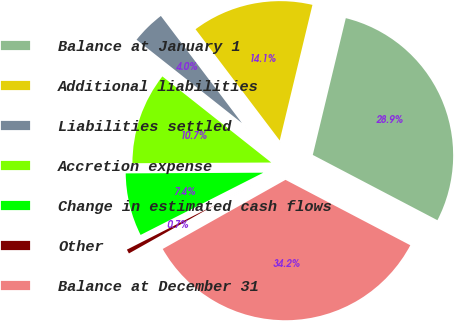Convert chart to OTSL. <chart><loc_0><loc_0><loc_500><loc_500><pie_chart><fcel>Balance at January 1<fcel>Additional liabilities<fcel>Liabilities settled<fcel>Accretion expense<fcel>Change in estimated cash flows<fcel>Other<fcel>Balance at December 31<nl><fcel>28.91%<fcel>14.08%<fcel>4.04%<fcel>10.73%<fcel>7.39%<fcel>0.69%<fcel>34.16%<nl></chart> 